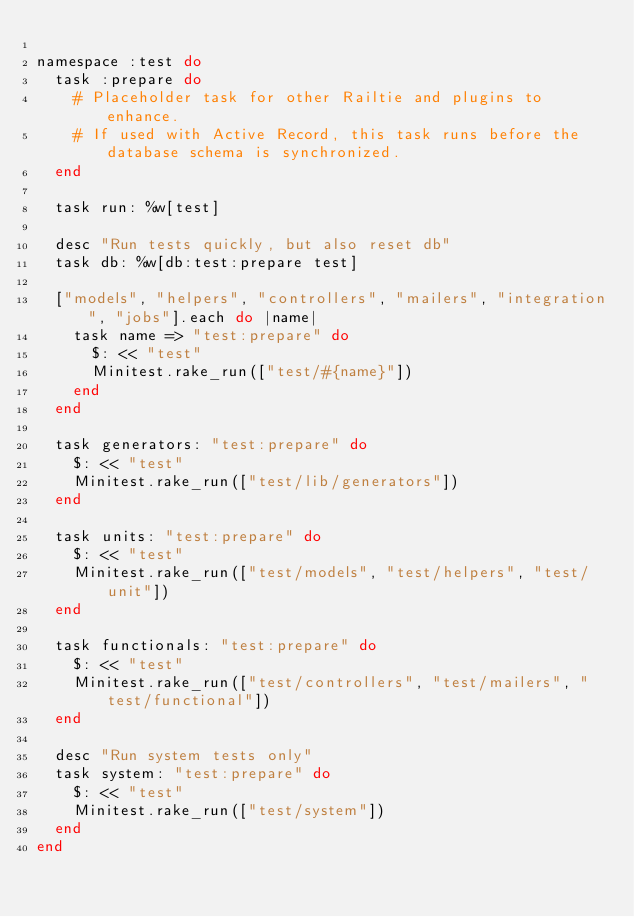Convert code to text. <code><loc_0><loc_0><loc_500><loc_500><_Ruby_>
namespace :test do
  task :prepare do
    # Placeholder task for other Railtie and plugins to enhance.
    # If used with Active Record, this task runs before the database schema is synchronized.
  end

  task run: %w[test]

  desc "Run tests quickly, but also reset db"
  task db: %w[db:test:prepare test]

  ["models", "helpers", "controllers", "mailers", "integration", "jobs"].each do |name|
    task name => "test:prepare" do
      $: << "test"
      Minitest.rake_run(["test/#{name}"])
    end
  end

  task generators: "test:prepare" do
    $: << "test"
    Minitest.rake_run(["test/lib/generators"])
  end

  task units: "test:prepare" do
    $: << "test"
    Minitest.rake_run(["test/models", "test/helpers", "test/unit"])
  end

  task functionals: "test:prepare" do
    $: << "test"
    Minitest.rake_run(["test/controllers", "test/mailers", "test/functional"])
  end

  desc "Run system tests only"
  task system: "test:prepare" do
    $: << "test"
    Minitest.rake_run(["test/system"])
  end
end
</code> 